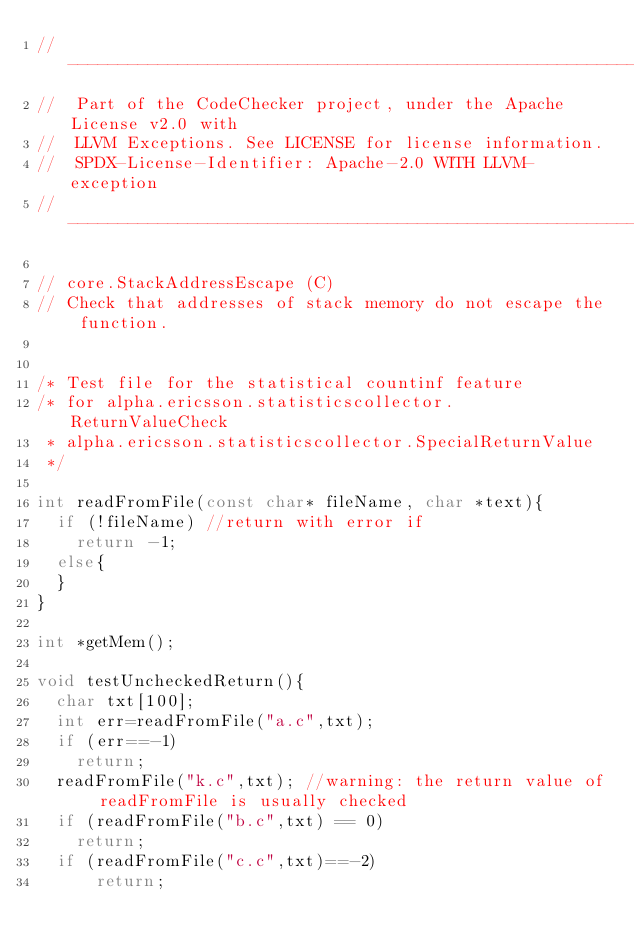<code> <loc_0><loc_0><loc_500><loc_500><_C++_>// -------------------------------------------------------------------------
//  Part of the CodeChecker project, under the Apache License v2.0 with
//  LLVM Exceptions. See LICENSE for license information.
//  SPDX-License-Identifier: Apache-2.0 WITH LLVM-exception
// -------------------------------------------------------------------------

// core.StackAddressEscape (C)
// Check that addresses of stack memory do not escape the function.


/* Test file for the statistical countinf feature
/* for alpha.ericsson.statisticscollector.ReturnValueCheck
 * alpha.ericsson.statisticscollector.SpecialReturnValue
 */

int readFromFile(const char* fileName, char *text){
  if (!fileName) //return with error if
    return -1;
  else{
  }
}

int *getMem();

void testUncheckedReturn(){
  char txt[100];
  int err=readFromFile("a.c",txt);
  if (err==-1)
    return;
  readFromFile("k.c",txt); //warning: the return value of readFromFile is usually checked
  if (readFromFile("b.c",txt) == 0)
    return;
  if (readFromFile("c.c",txt)==-2)
      return;</code> 